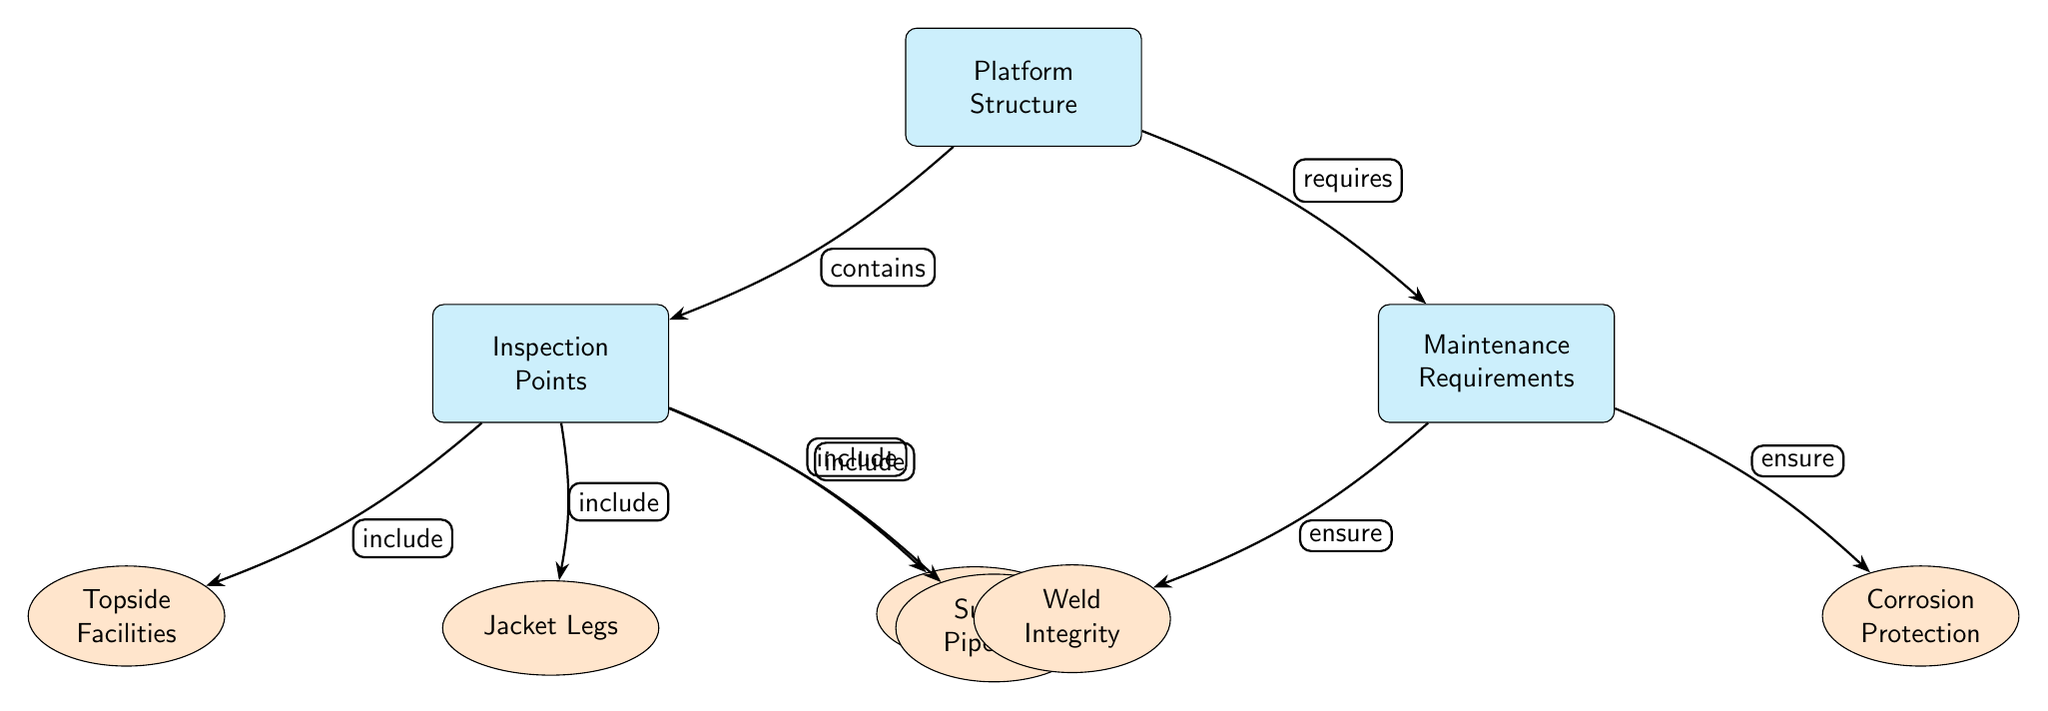What are the main components depicted in the diagram? The diagram includes three main components: Platform Structure, Inspection Points, and Maintenance Requirements. These components are clearly labeled in the main nodes of the diagram.
Answer: Platform Structure, Inspection Points, Maintenance Requirements How many sub-nodes are under Inspection Points? There are four sub-nodes listed under Inspection Points: Topside Facilities, Jacket Legs, Risers, and Subsea Pipelines. A quick count of the sub-nodes confirms this total.
Answer: 4 What type of inspection point is associated with jacket legs? The diagram indicates that Jacket Legs is a specific type of Inspection Point. It is connected as a sub-node under the main node Inspection Points, confirming its categorization.
Answer: Jacket Legs Which maintenance requirement ensures weld integrity? The diagram shows that Weld Integrity falls under the Maintenance Requirements and is explicitly linked to it as a sub-node with the label "ensure."
Answer: Weld Integrity What do the edges indicate between the main nodes? The edges connecting the main nodes indicate relationships: "contains" connects Platform Structure to Inspection Points, and "requires" connects Platform Structure to Maintenance Requirements, indicating how they are related.
Answer: Contains, Requires How is corrosion protection categorized in the diagram? Corrosion Protection is shown as a sub-node under Maintenance Requirements, signifying that it is one of the essential maintenance requirements needed for the platform.
Answer: Corrosion Protection What is the relationship between Inspection Points and Topside Facilities? The relationship is defined by the label "include," indicating that Topside Facilities is part of the broader category of Inspection Points. This connection clarifies that Topside Facilities falls under the inspection category.
Answer: Include What type of maintenance requirement relates to corrosion protection? The diagram explicitly connects Corrosion Protection to Maintenance Requirements with the phrase "ensure," indicating it is a crucial maintenance aspect that the structure needs to adhere to.
Answer: Ensure What is the overall focus of the diagram? The overall focus of the diagram is to illustrate the Structural Integrity Assessment of Offshore Platforms, detailing the components related to inspection and maintenance. This shows how various elements are interconnected.
Answer: Structural Integrity Assessment 